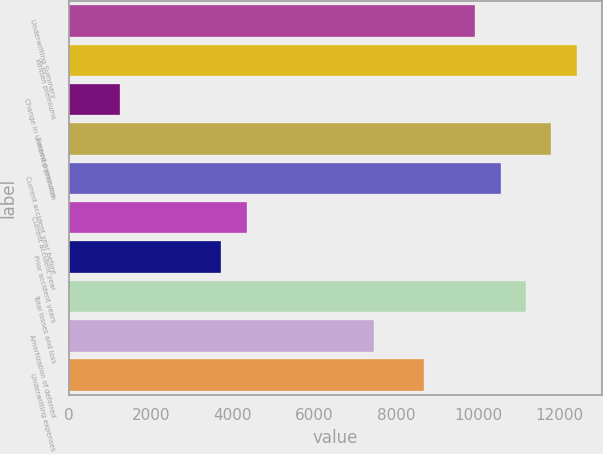<chart> <loc_0><loc_0><loc_500><loc_500><bar_chart><fcel>Underwriting Summary<fcel>Written premiums<fcel>Change in unearned premium<fcel>Earned premiums<fcel>Current accident year before<fcel>Current accident year<fcel>Prior accident years<fcel>Total losses and loss<fcel>Amortization of deferred<fcel>Underwriting expenses<nl><fcel>9932.2<fcel>12415<fcel>1242.4<fcel>11794.3<fcel>10552.9<fcel>4345.9<fcel>3725.2<fcel>11173.6<fcel>7449.4<fcel>8690.8<nl></chart> 